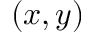<formula> <loc_0><loc_0><loc_500><loc_500>( x , y )</formula> 